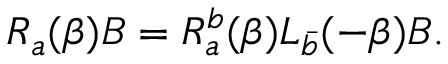Convert formula to latex. <formula><loc_0><loc_0><loc_500><loc_500>R _ { a } ( \beta ) B = R _ { a } ^ { b } ( \beta ) L _ { \bar { b } } ( - \beta ) B .</formula> 